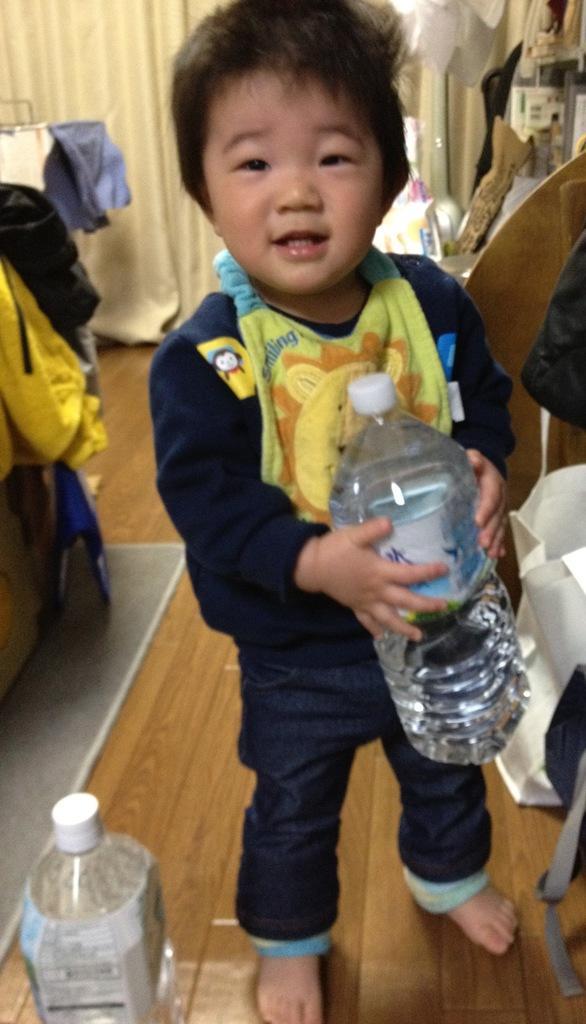Please provide a concise description of this image. This is a picture of a small boy wearing a blue shirt and short holding a water bottle and also we can see a water bottle beside him. 